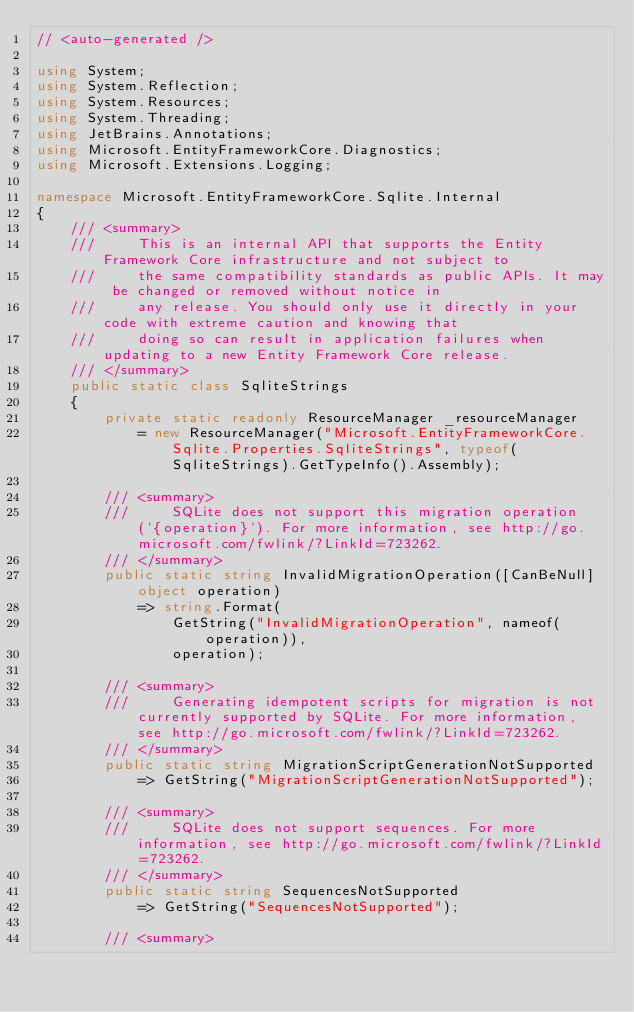<code> <loc_0><loc_0><loc_500><loc_500><_C#_>// <auto-generated />

using System;
using System.Reflection;
using System.Resources;
using System.Threading;
using JetBrains.Annotations;
using Microsoft.EntityFrameworkCore.Diagnostics;
using Microsoft.Extensions.Logging;

namespace Microsoft.EntityFrameworkCore.Sqlite.Internal
{
    /// <summary>
    ///     This is an internal API that supports the Entity Framework Core infrastructure and not subject to
    ///     the same compatibility standards as public APIs. It may be changed or removed without notice in
    ///     any release. You should only use it directly in your code with extreme caution and knowing that
    ///     doing so can result in application failures when updating to a new Entity Framework Core release.
    /// </summary>
    public static class SqliteStrings
    {
        private static readonly ResourceManager _resourceManager
            = new ResourceManager("Microsoft.EntityFrameworkCore.Sqlite.Properties.SqliteStrings", typeof(SqliteStrings).GetTypeInfo().Assembly);

        /// <summary>
        ///     SQLite does not support this migration operation ('{operation}'). For more information, see http://go.microsoft.com/fwlink/?LinkId=723262.
        /// </summary>
        public static string InvalidMigrationOperation([CanBeNull] object operation)
            => string.Format(
                GetString("InvalidMigrationOperation", nameof(operation)),
                operation);

        /// <summary>
        ///     Generating idempotent scripts for migration is not currently supported by SQLite. For more information, see http://go.microsoft.com/fwlink/?LinkId=723262.
        /// </summary>
        public static string MigrationScriptGenerationNotSupported
            => GetString("MigrationScriptGenerationNotSupported");

        /// <summary>
        ///     SQLite does not support sequences. For more information, see http://go.microsoft.com/fwlink/?LinkId=723262.
        /// </summary>
        public static string SequencesNotSupported
            => GetString("SequencesNotSupported");

        /// <summary></code> 